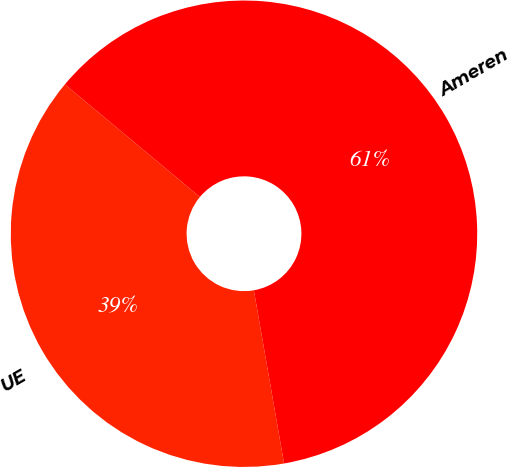Convert chart. <chart><loc_0><loc_0><loc_500><loc_500><pie_chart><fcel>UE<fcel>Ameren<nl><fcel>38.81%<fcel>61.19%<nl></chart> 